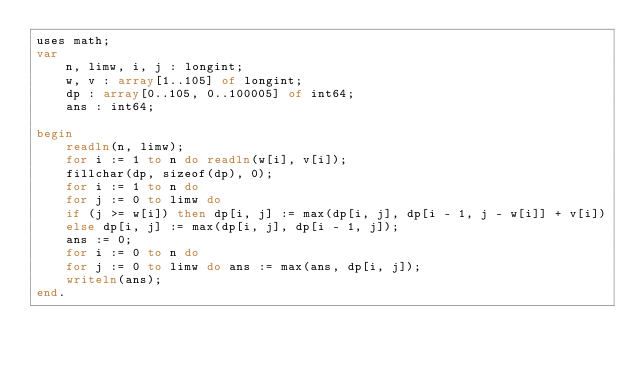Convert code to text. <code><loc_0><loc_0><loc_500><loc_500><_Pascal_>uses math;
var
    n, limw, i, j : longint;
    w, v : array[1..105] of longint;
    dp : array[0..105, 0..100005] of int64;
    ans : int64;

begin
    readln(n, limw);
    for i := 1 to n do readln(w[i], v[i]);
    fillchar(dp, sizeof(dp), 0);
    for i := 1 to n do
    for j := 0 to limw do
    if (j >= w[i]) then dp[i, j] := max(dp[i, j], dp[i - 1, j - w[i]] + v[i])
    else dp[i, j] := max(dp[i, j], dp[i - 1, j]);
    ans := 0;
    for i := 0 to n do
    for j := 0 to limw do ans := max(ans, dp[i, j]);
    writeln(ans);
end.</code> 